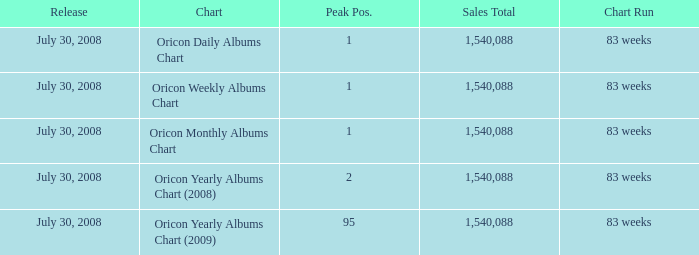Which Chart has a Peak Position of 1? Oricon Daily Albums Chart, Oricon Weekly Albums Chart, Oricon Monthly Albums Chart. 